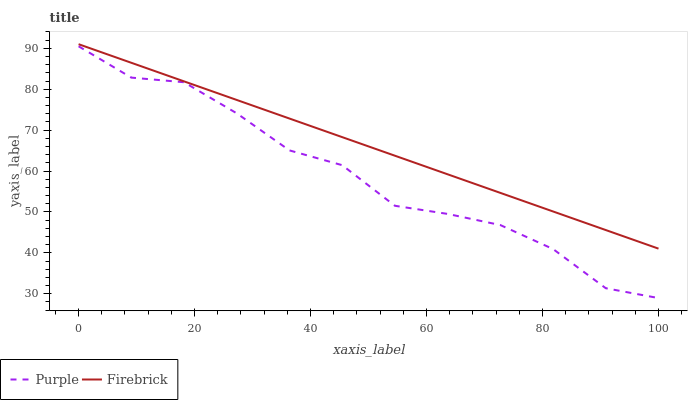Does Purple have the minimum area under the curve?
Answer yes or no. Yes. Does Firebrick have the maximum area under the curve?
Answer yes or no. Yes. Does Firebrick have the minimum area under the curve?
Answer yes or no. No. Is Firebrick the smoothest?
Answer yes or no. Yes. Is Purple the roughest?
Answer yes or no. Yes. Is Firebrick the roughest?
Answer yes or no. No. Does Purple have the lowest value?
Answer yes or no. Yes. Does Firebrick have the lowest value?
Answer yes or no. No. Does Firebrick have the highest value?
Answer yes or no. Yes. Is Purple less than Firebrick?
Answer yes or no. Yes. Is Firebrick greater than Purple?
Answer yes or no. Yes. Does Purple intersect Firebrick?
Answer yes or no. No. 